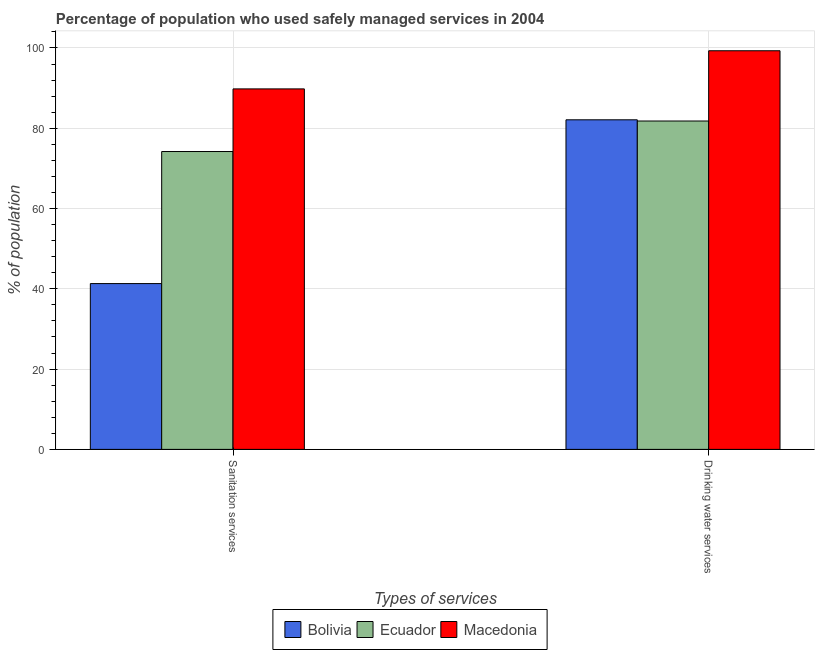How many groups of bars are there?
Your answer should be compact. 2. Are the number of bars per tick equal to the number of legend labels?
Make the answer very short. Yes. How many bars are there on the 1st tick from the left?
Your answer should be compact. 3. What is the label of the 2nd group of bars from the left?
Ensure brevity in your answer.  Drinking water services. What is the percentage of population who used drinking water services in Bolivia?
Keep it short and to the point. 82.1. Across all countries, what is the maximum percentage of population who used sanitation services?
Give a very brief answer. 89.8. Across all countries, what is the minimum percentage of population who used sanitation services?
Give a very brief answer. 41.3. In which country was the percentage of population who used sanitation services maximum?
Your answer should be compact. Macedonia. What is the total percentage of population who used drinking water services in the graph?
Provide a short and direct response. 263.2. What is the difference between the percentage of population who used drinking water services in Macedonia and that in Bolivia?
Your answer should be compact. 17.2. What is the difference between the percentage of population who used drinking water services in Bolivia and the percentage of population who used sanitation services in Ecuador?
Offer a terse response. 7.9. What is the average percentage of population who used sanitation services per country?
Your answer should be compact. 68.43. In how many countries, is the percentage of population who used drinking water services greater than 48 %?
Keep it short and to the point. 3. What is the ratio of the percentage of population who used sanitation services in Macedonia to that in Bolivia?
Your answer should be very brief. 2.17. How many bars are there?
Provide a succinct answer. 6. Does the graph contain any zero values?
Your answer should be compact. No. Where does the legend appear in the graph?
Provide a succinct answer. Bottom center. How many legend labels are there?
Keep it short and to the point. 3. What is the title of the graph?
Offer a very short reply. Percentage of population who used safely managed services in 2004. Does "St. Vincent and the Grenadines" appear as one of the legend labels in the graph?
Your answer should be compact. No. What is the label or title of the X-axis?
Provide a succinct answer. Types of services. What is the label or title of the Y-axis?
Offer a terse response. % of population. What is the % of population in Bolivia in Sanitation services?
Ensure brevity in your answer.  41.3. What is the % of population of Ecuador in Sanitation services?
Your response must be concise. 74.2. What is the % of population of Macedonia in Sanitation services?
Give a very brief answer. 89.8. What is the % of population in Bolivia in Drinking water services?
Give a very brief answer. 82.1. What is the % of population in Ecuador in Drinking water services?
Ensure brevity in your answer.  81.8. What is the % of population in Macedonia in Drinking water services?
Provide a succinct answer. 99.3. Across all Types of services, what is the maximum % of population in Bolivia?
Offer a terse response. 82.1. Across all Types of services, what is the maximum % of population in Ecuador?
Your response must be concise. 81.8. Across all Types of services, what is the maximum % of population in Macedonia?
Offer a terse response. 99.3. Across all Types of services, what is the minimum % of population of Bolivia?
Offer a terse response. 41.3. Across all Types of services, what is the minimum % of population in Ecuador?
Give a very brief answer. 74.2. Across all Types of services, what is the minimum % of population in Macedonia?
Ensure brevity in your answer.  89.8. What is the total % of population of Bolivia in the graph?
Give a very brief answer. 123.4. What is the total % of population in Ecuador in the graph?
Your response must be concise. 156. What is the total % of population in Macedonia in the graph?
Give a very brief answer. 189.1. What is the difference between the % of population in Bolivia in Sanitation services and that in Drinking water services?
Provide a short and direct response. -40.8. What is the difference between the % of population in Ecuador in Sanitation services and that in Drinking water services?
Make the answer very short. -7.6. What is the difference between the % of population in Bolivia in Sanitation services and the % of population in Ecuador in Drinking water services?
Your answer should be very brief. -40.5. What is the difference between the % of population of Bolivia in Sanitation services and the % of population of Macedonia in Drinking water services?
Your response must be concise. -58. What is the difference between the % of population of Ecuador in Sanitation services and the % of population of Macedonia in Drinking water services?
Ensure brevity in your answer.  -25.1. What is the average % of population of Bolivia per Types of services?
Offer a terse response. 61.7. What is the average % of population in Macedonia per Types of services?
Provide a succinct answer. 94.55. What is the difference between the % of population in Bolivia and % of population in Ecuador in Sanitation services?
Offer a very short reply. -32.9. What is the difference between the % of population of Bolivia and % of population of Macedonia in Sanitation services?
Your response must be concise. -48.5. What is the difference between the % of population in Ecuador and % of population in Macedonia in Sanitation services?
Offer a terse response. -15.6. What is the difference between the % of population of Bolivia and % of population of Macedonia in Drinking water services?
Give a very brief answer. -17.2. What is the difference between the % of population of Ecuador and % of population of Macedonia in Drinking water services?
Ensure brevity in your answer.  -17.5. What is the ratio of the % of population in Bolivia in Sanitation services to that in Drinking water services?
Offer a very short reply. 0.5. What is the ratio of the % of population in Ecuador in Sanitation services to that in Drinking water services?
Your answer should be very brief. 0.91. What is the ratio of the % of population of Macedonia in Sanitation services to that in Drinking water services?
Your answer should be compact. 0.9. What is the difference between the highest and the second highest % of population in Bolivia?
Make the answer very short. 40.8. What is the difference between the highest and the second highest % of population in Macedonia?
Your answer should be compact. 9.5. What is the difference between the highest and the lowest % of population in Bolivia?
Provide a succinct answer. 40.8. 